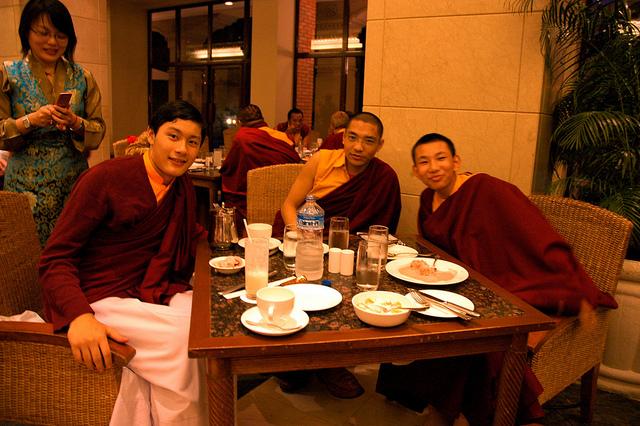What color is the table?
Write a very short answer. Brown. Are they monks?
Answer briefly. Yes. Are these people posing for this photo?
Be succinct. Yes. 